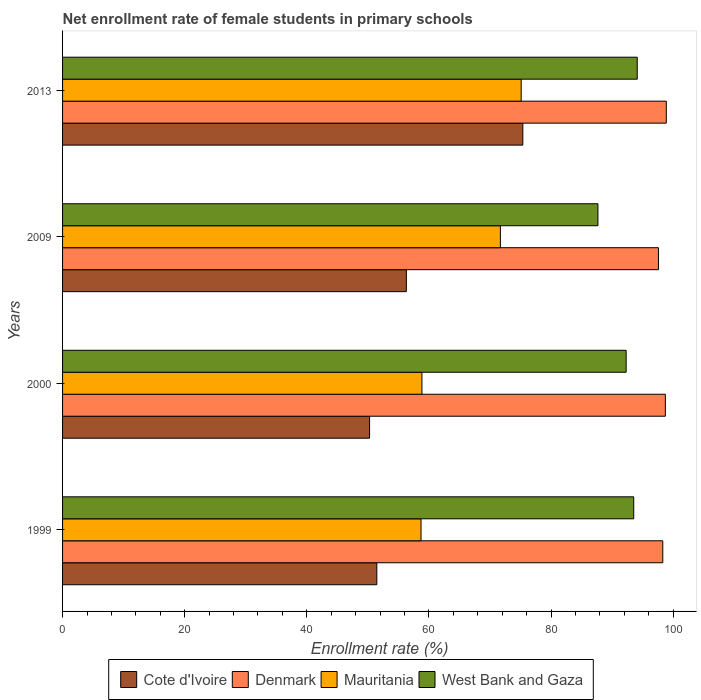How many different coloured bars are there?
Make the answer very short. 4. Are the number of bars on each tick of the Y-axis equal?
Give a very brief answer. Yes. How many bars are there on the 4th tick from the top?
Offer a terse response. 4. How many bars are there on the 3rd tick from the bottom?
Provide a succinct answer. 4. In how many cases, is the number of bars for a given year not equal to the number of legend labels?
Provide a succinct answer. 0. What is the net enrollment rate of female students in primary schools in Mauritania in 2013?
Offer a very short reply. 75.09. Across all years, what is the maximum net enrollment rate of female students in primary schools in Cote d'Ivoire?
Provide a short and direct response. 75.37. Across all years, what is the minimum net enrollment rate of female students in primary schools in West Bank and Gaza?
Your response must be concise. 87.66. In which year was the net enrollment rate of female students in primary schools in Mauritania maximum?
Keep it short and to the point. 2013. In which year was the net enrollment rate of female students in primary schools in Mauritania minimum?
Your answer should be compact. 1999. What is the total net enrollment rate of female students in primary schools in Mauritania in the graph?
Provide a succinct answer. 264.32. What is the difference between the net enrollment rate of female students in primary schools in Mauritania in 1999 and that in 2000?
Give a very brief answer. -0.15. What is the difference between the net enrollment rate of female students in primary schools in Cote d'Ivoire in 2000 and the net enrollment rate of female students in primary schools in Denmark in 2013?
Offer a very short reply. -48.59. What is the average net enrollment rate of female students in primary schools in West Bank and Gaza per year?
Provide a short and direct response. 91.89. In the year 2013, what is the difference between the net enrollment rate of female students in primary schools in West Bank and Gaza and net enrollment rate of female students in primary schools in Mauritania?
Your answer should be very brief. 19.01. In how many years, is the net enrollment rate of female students in primary schools in Cote d'Ivoire greater than 40 %?
Provide a succinct answer. 4. What is the ratio of the net enrollment rate of female students in primary schools in Cote d'Ivoire in 2000 to that in 2013?
Keep it short and to the point. 0.67. Is the net enrollment rate of female students in primary schools in West Bank and Gaza in 2009 less than that in 2013?
Give a very brief answer. Yes. Is the difference between the net enrollment rate of female students in primary schools in West Bank and Gaza in 2009 and 2013 greater than the difference between the net enrollment rate of female students in primary schools in Mauritania in 2009 and 2013?
Provide a short and direct response. No. What is the difference between the highest and the second highest net enrollment rate of female students in primary schools in Mauritania?
Offer a very short reply. 3.4. What is the difference between the highest and the lowest net enrollment rate of female students in primary schools in Mauritania?
Your response must be concise. 16.4. In how many years, is the net enrollment rate of female students in primary schools in West Bank and Gaza greater than the average net enrollment rate of female students in primary schools in West Bank and Gaza taken over all years?
Provide a short and direct response. 3. What does the 1st bar from the top in 1999 represents?
Your answer should be very brief. West Bank and Gaza. What does the 3rd bar from the bottom in 1999 represents?
Your response must be concise. Mauritania. Is it the case that in every year, the sum of the net enrollment rate of female students in primary schools in Denmark and net enrollment rate of female students in primary schools in Cote d'Ivoire is greater than the net enrollment rate of female students in primary schools in Mauritania?
Offer a terse response. Yes. How many bars are there?
Keep it short and to the point. 16. Are all the bars in the graph horizontal?
Offer a terse response. Yes. How many years are there in the graph?
Ensure brevity in your answer.  4. What is the difference between two consecutive major ticks on the X-axis?
Offer a terse response. 20. Does the graph contain any zero values?
Keep it short and to the point. No. Where does the legend appear in the graph?
Provide a short and direct response. Bottom center. How many legend labels are there?
Offer a terse response. 4. How are the legend labels stacked?
Offer a very short reply. Horizontal. What is the title of the graph?
Your answer should be compact. Net enrollment rate of female students in primary schools. Does "Syrian Arab Republic" appear as one of the legend labels in the graph?
Ensure brevity in your answer.  No. What is the label or title of the X-axis?
Make the answer very short. Enrollment rate (%). What is the Enrollment rate (%) of Cote d'Ivoire in 1999?
Make the answer very short. 51.46. What is the Enrollment rate (%) of Denmark in 1999?
Ensure brevity in your answer.  98.28. What is the Enrollment rate (%) in Mauritania in 1999?
Offer a terse response. 58.69. What is the Enrollment rate (%) in West Bank and Gaza in 1999?
Provide a short and direct response. 93.53. What is the Enrollment rate (%) in Cote d'Ivoire in 2000?
Offer a very short reply. 50.27. What is the Enrollment rate (%) of Denmark in 2000?
Your answer should be compact. 98.7. What is the Enrollment rate (%) of Mauritania in 2000?
Your answer should be compact. 58.84. What is the Enrollment rate (%) of West Bank and Gaza in 2000?
Offer a terse response. 92.28. What is the Enrollment rate (%) in Cote d'Ivoire in 2009?
Keep it short and to the point. 56.29. What is the Enrollment rate (%) in Denmark in 2009?
Provide a short and direct response. 97.57. What is the Enrollment rate (%) of Mauritania in 2009?
Ensure brevity in your answer.  71.69. What is the Enrollment rate (%) of West Bank and Gaza in 2009?
Give a very brief answer. 87.66. What is the Enrollment rate (%) in Cote d'Ivoire in 2013?
Offer a very short reply. 75.37. What is the Enrollment rate (%) of Denmark in 2013?
Provide a short and direct response. 98.86. What is the Enrollment rate (%) in Mauritania in 2013?
Your answer should be very brief. 75.09. What is the Enrollment rate (%) in West Bank and Gaza in 2013?
Give a very brief answer. 94.1. Across all years, what is the maximum Enrollment rate (%) of Cote d'Ivoire?
Keep it short and to the point. 75.37. Across all years, what is the maximum Enrollment rate (%) of Denmark?
Your answer should be compact. 98.86. Across all years, what is the maximum Enrollment rate (%) of Mauritania?
Give a very brief answer. 75.09. Across all years, what is the maximum Enrollment rate (%) of West Bank and Gaza?
Offer a terse response. 94.1. Across all years, what is the minimum Enrollment rate (%) of Cote d'Ivoire?
Your answer should be compact. 50.27. Across all years, what is the minimum Enrollment rate (%) in Denmark?
Your answer should be compact. 97.57. Across all years, what is the minimum Enrollment rate (%) in Mauritania?
Offer a very short reply. 58.69. Across all years, what is the minimum Enrollment rate (%) of West Bank and Gaza?
Your response must be concise. 87.66. What is the total Enrollment rate (%) of Cote d'Ivoire in the graph?
Give a very brief answer. 233.39. What is the total Enrollment rate (%) of Denmark in the graph?
Your answer should be very brief. 393.42. What is the total Enrollment rate (%) in Mauritania in the graph?
Offer a terse response. 264.32. What is the total Enrollment rate (%) in West Bank and Gaza in the graph?
Your answer should be compact. 367.58. What is the difference between the Enrollment rate (%) of Cote d'Ivoire in 1999 and that in 2000?
Provide a succinct answer. 1.19. What is the difference between the Enrollment rate (%) of Denmark in 1999 and that in 2000?
Give a very brief answer. -0.42. What is the difference between the Enrollment rate (%) of Mauritania in 1999 and that in 2000?
Offer a terse response. -0.15. What is the difference between the Enrollment rate (%) in West Bank and Gaza in 1999 and that in 2000?
Offer a very short reply. 1.24. What is the difference between the Enrollment rate (%) of Cote d'Ivoire in 1999 and that in 2009?
Your answer should be compact. -4.83. What is the difference between the Enrollment rate (%) of Denmark in 1999 and that in 2009?
Keep it short and to the point. 0.71. What is the difference between the Enrollment rate (%) of Mauritania in 1999 and that in 2009?
Offer a very short reply. -13. What is the difference between the Enrollment rate (%) of West Bank and Gaza in 1999 and that in 2009?
Your answer should be compact. 5.86. What is the difference between the Enrollment rate (%) in Cote d'Ivoire in 1999 and that in 2013?
Keep it short and to the point. -23.91. What is the difference between the Enrollment rate (%) in Denmark in 1999 and that in 2013?
Make the answer very short. -0.58. What is the difference between the Enrollment rate (%) of Mauritania in 1999 and that in 2013?
Give a very brief answer. -16.4. What is the difference between the Enrollment rate (%) in West Bank and Gaza in 1999 and that in 2013?
Keep it short and to the point. -0.58. What is the difference between the Enrollment rate (%) of Cote d'Ivoire in 2000 and that in 2009?
Your answer should be compact. -6.02. What is the difference between the Enrollment rate (%) of Denmark in 2000 and that in 2009?
Make the answer very short. 1.13. What is the difference between the Enrollment rate (%) in Mauritania in 2000 and that in 2009?
Give a very brief answer. -12.85. What is the difference between the Enrollment rate (%) in West Bank and Gaza in 2000 and that in 2009?
Your response must be concise. 4.62. What is the difference between the Enrollment rate (%) in Cote d'Ivoire in 2000 and that in 2013?
Provide a succinct answer. -25.1. What is the difference between the Enrollment rate (%) in Denmark in 2000 and that in 2013?
Make the answer very short. -0.16. What is the difference between the Enrollment rate (%) of Mauritania in 2000 and that in 2013?
Keep it short and to the point. -16.25. What is the difference between the Enrollment rate (%) in West Bank and Gaza in 2000 and that in 2013?
Offer a very short reply. -1.82. What is the difference between the Enrollment rate (%) in Cote d'Ivoire in 2009 and that in 2013?
Offer a terse response. -19.07. What is the difference between the Enrollment rate (%) in Denmark in 2009 and that in 2013?
Your answer should be compact. -1.29. What is the difference between the Enrollment rate (%) of Mauritania in 2009 and that in 2013?
Give a very brief answer. -3.4. What is the difference between the Enrollment rate (%) in West Bank and Gaza in 2009 and that in 2013?
Keep it short and to the point. -6.44. What is the difference between the Enrollment rate (%) in Cote d'Ivoire in 1999 and the Enrollment rate (%) in Denmark in 2000?
Provide a short and direct response. -47.24. What is the difference between the Enrollment rate (%) in Cote d'Ivoire in 1999 and the Enrollment rate (%) in Mauritania in 2000?
Ensure brevity in your answer.  -7.39. What is the difference between the Enrollment rate (%) of Cote d'Ivoire in 1999 and the Enrollment rate (%) of West Bank and Gaza in 2000?
Offer a very short reply. -40.82. What is the difference between the Enrollment rate (%) in Denmark in 1999 and the Enrollment rate (%) in Mauritania in 2000?
Your answer should be compact. 39.44. What is the difference between the Enrollment rate (%) of Denmark in 1999 and the Enrollment rate (%) of West Bank and Gaza in 2000?
Provide a succinct answer. 6. What is the difference between the Enrollment rate (%) in Mauritania in 1999 and the Enrollment rate (%) in West Bank and Gaza in 2000?
Keep it short and to the point. -33.59. What is the difference between the Enrollment rate (%) in Cote d'Ivoire in 1999 and the Enrollment rate (%) in Denmark in 2009?
Offer a very short reply. -46.12. What is the difference between the Enrollment rate (%) of Cote d'Ivoire in 1999 and the Enrollment rate (%) of Mauritania in 2009?
Your response must be concise. -20.23. What is the difference between the Enrollment rate (%) in Cote d'Ivoire in 1999 and the Enrollment rate (%) in West Bank and Gaza in 2009?
Ensure brevity in your answer.  -36.21. What is the difference between the Enrollment rate (%) in Denmark in 1999 and the Enrollment rate (%) in Mauritania in 2009?
Your answer should be compact. 26.59. What is the difference between the Enrollment rate (%) of Denmark in 1999 and the Enrollment rate (%) of West Bank and Gaza in 2009?
Your response must be concise. 10.62. What is the difference between the Enrollment rate (%) in Mauritania in 1999 and the Enrollment rate (%) in West Bank and Gaza in 2009?
Offer a terse response. -28.97. What is the difference between the Enrollment rate (%) of Cote d'Ivoire in 1999 and the Enrollment rate (%) of Denmark in 2013?
Your answer should be compact. -47.4. What is the difference between the Enrollment rate (%) in Cote d'Ivoire in 1999 and the Enrollment rate (%) in Mauritania in 2013?
Your answer should be compact. -23.64. What is the difference between the Enrollment rate (%) of Cote d'Ivoire in 1999 and the Enrollment rate (%) of West Bank and Gaza in 2013?
Provide a succinct answer. -42.64. What is the difference between the Enrollment rate (%) of Denmark in 1999 and the Enrollment rate (%) of Mauritania in 2013?
Provide a succinct answer. 23.19. What is the difference between the Enrollment rate (%) in Denmark in 1999 and the Enrollment rate (%) in West Bank and Gaza in 2013?
Ensure brevity in your answer.  4.18. What is the difference between the Enrollment rate (%) of Mauritania in 1999 and the Enrollment rate (%) of West Bank and Gaza in 2013?
Keep it short and to the point. -35.41. What is the difference between the Enrollment rate (%) of Cote d'Ivoire in 2000 and the Enrollment rate (%) of Denmark in 2009?
Provide a short and direct response. -47.3. What is the difference between the Enrollment rate (%) in Cote d'Ivoire in 2000 and the Enrollment rate (%) in Mauritania in 2009?
Provide a short and direct response. -21.42. What is the difference between the Enrollment rate (%) in Cote d'Ivoire in 2000 and the Enrollment rate (%) in West Bank and Gaza in 2009?
Your answer should be compact. -37.39. What is the difference between the Enrollment rate (%) in Denmark in 2000 and the Enrollment rate (%) in Mauritania in 2009?
Give a very brief answer. 27.01. What is the difference between the Enrollment rate (%) of Denmark in 2000 and the Enrollment rate (%) of West Bank and Gaza in 2009?
Offer a very short reply. 11.04. What is the difference between the Enrollment rate (%) of Mauritania in 2000 and the Enrollment rate (%) of West Bank and Gaza in 2009?
Offer a very short reply. -28.82. What is the difference between the Enrollment rate (%) in Cote d'Ivoire in 2000 and the Enrollment rate (%) in Denmark in 2013?
Make the answer very short. -48.59. What is the difference between the Enrollment rate (%) of Cote d'Ivoire in 2000 and the Enrollment rate (%) of Mauritania in 2013?
Offer a very short reply. -24.82. What is the difference between the Enrollment rate (%) in Cote d'Ivoire in 2000 and the Enrollment rate (%) in West Bank and Gaza in 2013?
Give a very brief answer. -43.83. What is the difference between the Enrollment rate (%) of Denmark in 2000 and the Enrollment rate (%) of Mauritania in 2013?
Your answer should be very brief. 23.61. What is the difference between the Enrollment rate (%) in Denmark in 2000 and the Enrollment rate (%) in West Bank and Gaza in 2013?
Make the answer very short. 4.6. What is the difference between the Enrollment rate (%) in Mauritania in 2000 and the Enrollment rate (%) in West Bank and Gaza in 2013?
Offer a very short reply. -35.26. What is the difference between the Enrollment rate (%) in Cote d'Ivoire in 2009 and the Enrollment rate (%) in Denmark in 2013?
Provide a short and direct response. -42.57. What is the difference between the Enrollment rate (%) in Cote d'Ivoire in 2009 and the Enrollment rate (%) in Mauritania in 2013?
Offer a very short reply. -18.8. What is the difference between the Enrollment rate (%) of Cote d'Ivoire in 2009 and the Enrollment rate (%) of West Bank and Gaza in 2013?
Ensure brevity in your answer.  -37.81. What is the difference between the Enrollment rate (%) of Denmark in 2009 and the Enrollment rate (%) of Mauritania in 2013?
Provide a succinct answer. 22.48. What is the difference between the Enrollment rate (%) in Denmark in 2009 and the Enrollment rate (%) in West Bank and Gaza in 2013?
Provide a short and direct response. 3.47. What is the difference between the Enrollment rate (%) in Mauritania in 2009 and the Enrollment rate (%) in West Bank and Gaza in 2013?
Ensure brevity in your answer.  -22.41. What is the average Enrollment rate (%) of Cote d'Ivoire per year?
Ensure brevity in your answer.  58.35. What is the average Enrollment rate (%) in Denmark per year?
Give a very brief answer. 98.36. What is the average Enrollment rate (%) of Mauritania per year?
Offer a very short reply. 66.08. What is the average Enrollment rate (%) of West Bank and Gaza per year?
Provide a short and direct response. 91.89. In the year 1999, what is the difference between the Enrollment rate (%) in Cote d'Ivoire and Enrollment rate (%) in Denmark?
Your answer should be very brief. -46.82. In the year 1999, what is the difference between the Enrollment rate (%) in Cote d'Ivoire and Enrollment rate (%) in Mauritania?
Offer a very short reply. -7.24. In the year 1999, what is the difference between the Enrollment rate (%) of Cote d'Ivoire and Enrollment rate (%) of West Bank and Gaza?
Offer a very short reply. -42.07. In the year 1999, what is the difference between the Enrollment rate (%) in Denmark and Enrollment rate (%) in Mauritania?
Provide a short and direct response. 39.59. In the year 1999, what is the difference between the Enrollment rate (%) in Denmark and Enrollment rate (%) in West Bank and Gaza?
Your answer should be compact. 4.76. In the year 1999, what is the difference between the Enrollment rate (%) in Mauritania and Enrollment rate (%) in West Bank and Gaza?
Keep it short and to the point. -34.83. In the year 2000, what is the difference between the Enrollment rate (%) of Cote d'Ivoire and Enrollment rate (%) of Denmark?
Make the answer very short. -48.43. In the year 2000, what is the difference between the Enrollment rate (%) of Cote d'Ivoire and Enrollment rate (%) of Mauritania?
Offer a very short reply. -8.57. In the year 2000, what is the difference between the Enrollment rate (%) of Cote d'Ivoire and Enrollment rate (%) of West Bank and Gaza?
Offer a terse response. -42.01. In the year 2000, what is the difference between the Enrollment rate (%) of Denmark and Enrollment rate (%) of Mauritania?
Your response must be concise. 39.86. In the year 2000, what is the difference between the Enrollment rate (%) of Denmark and Enrollment rate (%) of West Bank and Gaza?
Offer a terse response. 6.42. In the year 2000, what is the difference between the Enrollment rate (%) of Mauritania and Enrollment rate (%) of West Bank and Gaza?
Provide a short and direct response. -33.44. In the year 2009, what is the difference between the Enrollment rate (%) of Cote d'Ivoire and Enrollment rate (%) of Denmark?
Provide a short and direct response. -41.28. In the year 2009, what is the difference between the Enrollment rate (%) of Cote d'Ivoire and Enrollment rate (%) of Mauritania?
Keep it short and to the point. -15.4. In the year 2009, what is the difference between the Enrollment rate (%) of Cote d'Ivoire and Enrollment rate (%) of West Bank and Gaza?
Offer a terse response. -31.37. In the year 2009, what is the difference between the Enrollment rate (%) of Denmark and Enrollment rate (%) of Mauritania?
Give a very brief answer. 25.88. In the year 2009, what is the difference between the Enrollment rate (%) of Denmark and Enrollment rate (%) of West Bank and Gaza?
Provide a short and direct response. 9.91. In the year 2009, what is the difference between the Enrollment rate (%) of Mauritania and Enrollment rate (%) of West Bank and Gaza?
Your response must be concise. -15.97. In the year 2013, what is the difference between the Enrollment rate (%) of Cote d'Ivoire and Enrollment rate (%) of Denmark?
Your answer should be compact. -23.49. In the year 2013, what is the difference between the Enrollment rate (%) of Cote d'Ivoire and Enrollment rate (%) of Mauritania?
Ensure brevity in your answer.  0.27. In the year 2013, what is the difference between the Enrollment rate (%) of Cote d'Ivoire and Enrollment rate (%) of West Bank and Gaza?
Your answer should be compact. -18.74. In the year 2013, what is the difference between the Enrollment rate (%) of Denmark and Enrollment rate (%) of Mauritania?
Give a very brief answer. 23.77. In the year 2013, what is the difference between the Enrollment rate (%) of Denmark and Enrollment rate (%) of West Bank and Gaza?
Your answer should be very brief. 4.76. In the year 2013, what is the difference between the Enrollment rate (%) in Mauritania and Enrollment rate (%) in West Bank and Gaza?
Offer a very short reply. -19.01. What is the ratio of the Enrollment rate (%) in Cote d'Ivoire in 1999 to that in 2000?
Offer a terse response. 1.02. What is the ratio of the Enrollment rate (%) of Denmark in 1999 to that in 2000?
Keep it short and to the point. 1. What is the ratio of the Enrollment rate (%) of West Bank and Gaza in 1999 to that in 2000?
Provide a succinct answer. 1.01. What is the ratio of the Enrollment rate (%) in Cote d'Ivoire in 1999 to that in 2009?
Your answer should be compact. 0.91. What is the ratio of the Enrollment rate (%) in Denmark in 1999 to that in 2009?
Keep it short and to the point. 1.01. What is the ratio of the Enrollment rate (%) of Mauritania in 1999 to that in 2009?
Provide a short and direct response. 0.82. What is the ratio of the Enrollment rate (%) of West Bank and Gaza in 1999 to that in 2009?
Make the answer very short. 1.07. What is the ratio of the Enrollment rate (%) of Cote d'Ivoire in 1999 to that in 2013?
Provide a short and direct response. 0.68. What is the ratio of the Enrollment rate (%) in Mauritania in 1999 to that in 2013?
Provide a succinct answer. 0.78. What is the ratio of the Enrollment rate (%) in Cote d'Ivoire in 2000 to that in 2009?
Make the answer very short. 0.89. What is the ratio of the Enrollment rate (%) of Denmark in 2000 to that in 2009?
Your response must be concise. 1.01. What is the ratio of the Enrollment rate (%) in Mauritania in 2000 to that in 2009?
Ensure brevity in your answer.  0.82. What is the ratio of the Enrollment rate (%) of West Bank and Gaza in 2000 to that in 2009?
Your response must be concise. 1.05. What is the ratio of the Enrollment rate (%) of Cote d'Ivoire in 2000 to that in 2013?
Your response must be concise. 0.67. What is the ratio of the Enrollment rate (%) of Mauritania in 2000 to that in 2013?
Give a very brief answer. 0.78. What is the ratio of the Enrollment rate (%) of West Bank and Gaza in 2000 to that in 2013?
Ensure brevity in your answer.  0.98. What is the ratio of the Enrollment rate (%) of Cote d'Ivoire in 2009 to that in 2013?
Offer a very short reply. 0.75. What is the ratio of the Enrollment rate (%) in Denmark in 2009 to that in 2013?
Offer a terse response. 0.99. What is the ratio of the Enrollment rate (%) of Mauritania in 2009 to that in 2013?
Offer a terse response. 0.95. What is the ratio of the Enrollment rate (%) in West Bank and Gaza in 2009 to that in 2013?
Your response must be concise. 0.93. What is the difference between the highest and the second highest Enrollment rate (%) in Cote d'Ivoire?
Provide a succinct answer. 19.07. What is the difference between the highest and the second highest Enrollment rate (%) in Denmark?
Give a very brief answer. 0.16. What is the difference between the highest and the second highest Enrollment rate (%) in Mauritania?
Keep it short and to the point. 3.4. What is the difference between the highest and the second highest Enrollment rate (%) in West Bank and Gaza?
Offer a very short reply. 0.58. What is the difference between the highest and the lowest Enrollment rate (%) in Cote d'Ivoire?
Your answer should be very brief. 25.1. What is the difference between the highest and the lowest Enrollment rate (%) in Denmark?
Offer a very short reply. 1.29. What is the difference between the highest and the lowest Enrollment rate (%) of Mauritania?
Your response must be concise. 16.4. What is the difference between the highest and the lowest Enrollment rate (%) of West Bank and Gaza?
Keep it short and to the point. 6.44. 